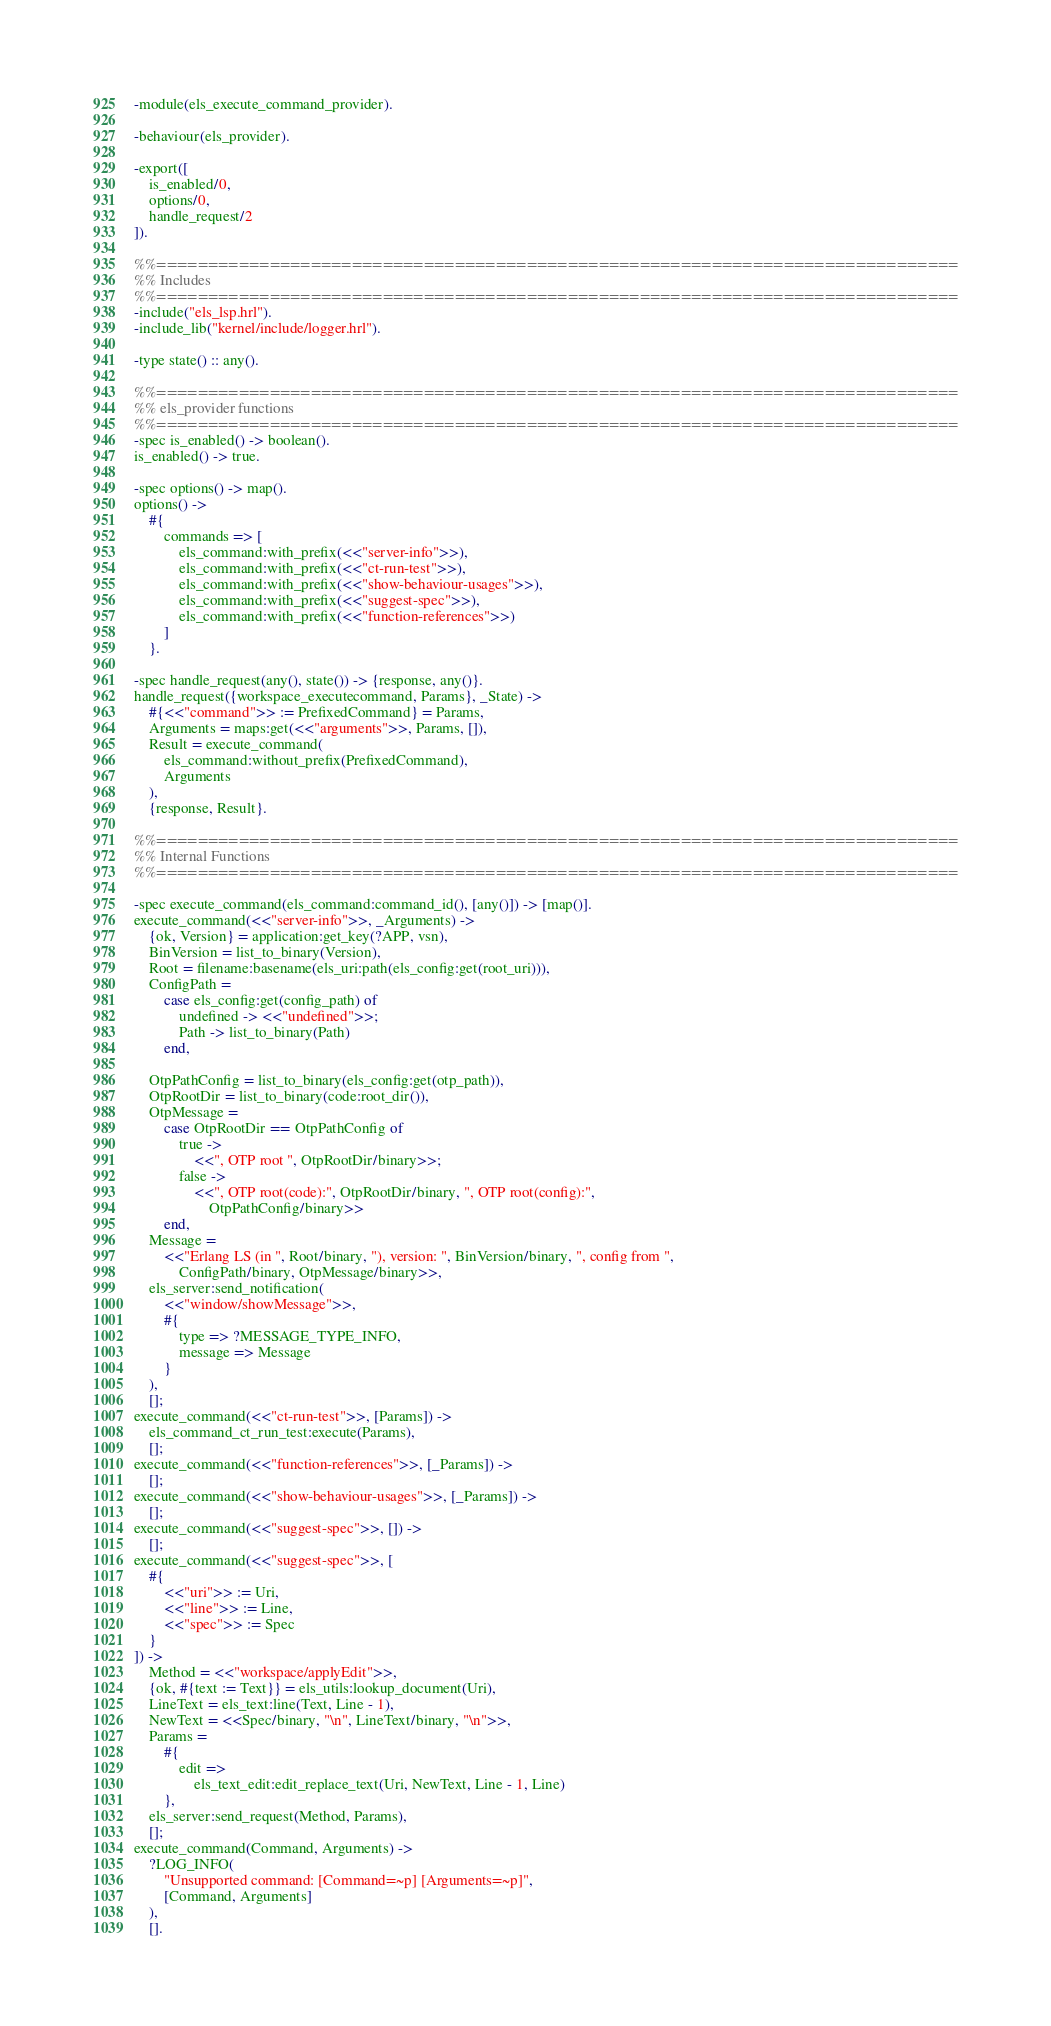Convert code to text. <code><loc_0><loc_0><loc_500><loc_500><_Erlang_>-module(els_execute_command_provider).

-behaviour(els_provider).

-export([
    is_enabled/0,
    options/0,
    handle_request/2
]).

%%==============================================================================
%% Includes
%%==============================================================================
-include("els_lsp.hrl").
-include_lib("kernel/include/logger.hrl").

-type state() :: any().

%%==============================================================================
%% els_provider functions
%%==============================================================================
-spec is_enabled() -> boolean().
is_enabled() -> true.

-spec options() -> map().
options() ->
    #{
        commands => [
            els_command:with_prefix(<<"server-info">>),
            els_command:with_prefix(<<"ct-run-test">>),
            els_command:with_prefix(<<"show-behaviour-usages">>),
            els_command:with_prefix(<<"suggest-spec">>),
            els_command:with_prefix(<<"function-references">>)
        ]
    }.

-spec handle_request(any(), state()) -> {response, any()}.
handle_request({workspace_executecommand, Params}, _State) ->
    #{<<"command">> := PrefixedCommand} = Params,
    Arguments = maps:get(<<"arguments">>, Params, []),
    Result = execute_command(
        els_command:without_prefix(PrefixedCommand),
        Arguments
    ),
    {response, Result}.

%%==============================================================================
%% Internal Functions
%%==============================================================================

-spec execute_command(els_command:command_id(), [any()]) -> [map()].
execute_command(<<"server-info">>, _Arguments) ->
    {ok, Version} = application:get_key(?APP, vsn),
    BinVersion = list_to_binary(Version),
    Root = filename:basename(els_uri:path(els_config:get(root_uri))),
    ConfigPath =
        case els_config:get(config_path) of
            undefined -> <<"undefined">>;
            Path -> list_to_binary(Path)
        end,

    OtpPathConfig = list_to_binary(els_config:get(otp_path)),
    OtpRootDir = list_to_binary(code:root_dir()),
    OtpMessage =
        case OtpRootDir == OtpPathConfig of
            true ->
                <<", OTP root ", OtpRootDir/binary>>;
            false ->
                <<", OTP root(code):", OtpRootDir/binary, ", OTP root(config):",
                    OtpPathConfig/binary>>
        end,
    Message =
        <<"Erlang LS (in ", Root/binary, "), version: ", BinVersion/binary, ", config from ",
            ConfigPath/binary, OtpMessage/binary>>,
    els_server:send_notification(
        <<"window/showMessage">>,
        #{
            type => ?MESSAGE_TYPE_INFO,
            message => Message
        }
    ),
    [];
execute_command(<<"ct-run-test">>, [Params]) ->
    els_command_ct_run_test:execute(Params),
    [];
execute_command(<<"function-references">>, [_Params]) ->
    [];
execute_command(<<"show-behaviour-usages">>, [_Params]) ->
    [];
execute_command(<<"suggest-spec">>, []) ->
    [];
execute_command(<<"suggest-spec">>, [
    #{
        <<"uri">> := Uri,
        <<"line">> := Line,
        <<"spec">> := Spec
    }
]) ->
    Method = <<"workspace/applyEdit">>,
    {ok, #{text := Text}} = els_utils:lookup_document(Uri),
    LineText = els_text:line(Text, Line - 1),
    NewText = <<Spec/binary, "\n", LineText/binary, "\n">>,
    Params =
        #{
            edit =>
                els_text_edit:edit_replace_text(Uri, NewText, Line - 1, Line)
        },
    els_server:send_request(Method, Params),
    [];
execute_command(Command, Arguments) ->
    ?LOG_INFO(
        "Unsupported command: [Command=~p] [Arguments=~p]",
        [Command, Arguments]
    ),
    [].
</code> 